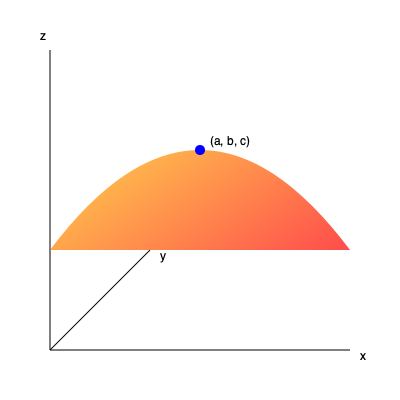Consider the function $f(x,y) = x^2 + y^2 - 2xy + 2x - 4y + 5$ visualized as a paraboloid in 3D space above. Find the critical point(s) of this function and determine whether it represents a local maximum, local minimum, or saddle point. Justify your answer using the second partial derivative test. To find the critical points and classify them, we'll follow these steps:

1) Find the partial derivatives:
   $\frac{\partial f}{\partial x} = 2x - 2y + 2$
   $\frac{\partial f}{\partial y} = 2y - 2x - 4$

2) Set both partial derivatives to zero and solve:
   $2x - 2y + 2 = 0$ and $2y - 2x - 4 = 0$
   Adding these equations: $-2 = 0$, which is a contradiction.
   
   Subtracting the second from the first:
   $4x - 4y + 6 = 0$
   $x - y + \frac{3}{2} = 0$
   $y = x + \frac{3}{2}$

   Substituting this into $2x - 2y + 2 = 0$:
   $2x - 2(x + \frac{3}{2}) + 2 = 0$
   $2x - 2x - 3 + 2 = 0$
   $-1 = 0$, another contradiction.

3) Since we can't find a solution, there are no critical points in the interior of the domain.

4) To be thorough, we should check the behavior at infinity:
   As $x$ or $y$ approach infinity, $f(x,y)$ approaches positive infinity due to the $x^2$ and $y^2$ terms.

5) The absence of interior critical points and the behavior at infinity suggest that the global minimum (if it exists) must occur on the boundary of any closed, bounded region containing the origin.

6) While we can't apply the second partial derivative test (as there are no critical points), we can still analyze the shape:
   $\frac{\partial^2 f}{\partial x^2} = 2$
   $\frac{\partial^2 f}{\partial y^2} = 2$
   $\frac{\partial^2 f}{\partial x \partial y} = -2$

   The Hessian matrix is:
   $H = \begin{bmatrix} 2 & -2 \\ -2 & 2 \end{bmatrix}$

   The determinant of H is: $det(H) = 2(2) - (-2)(-2) = 0$

   This indicates that the surface has a parabolic shape (like a parabolic cylinder), which is consistent with our observation of no interior critical points.
Answer: No interior critical points. Paraboloid opens upward, suggesting a global minimum on the boundary of any closed, bounded region containing the origin. 